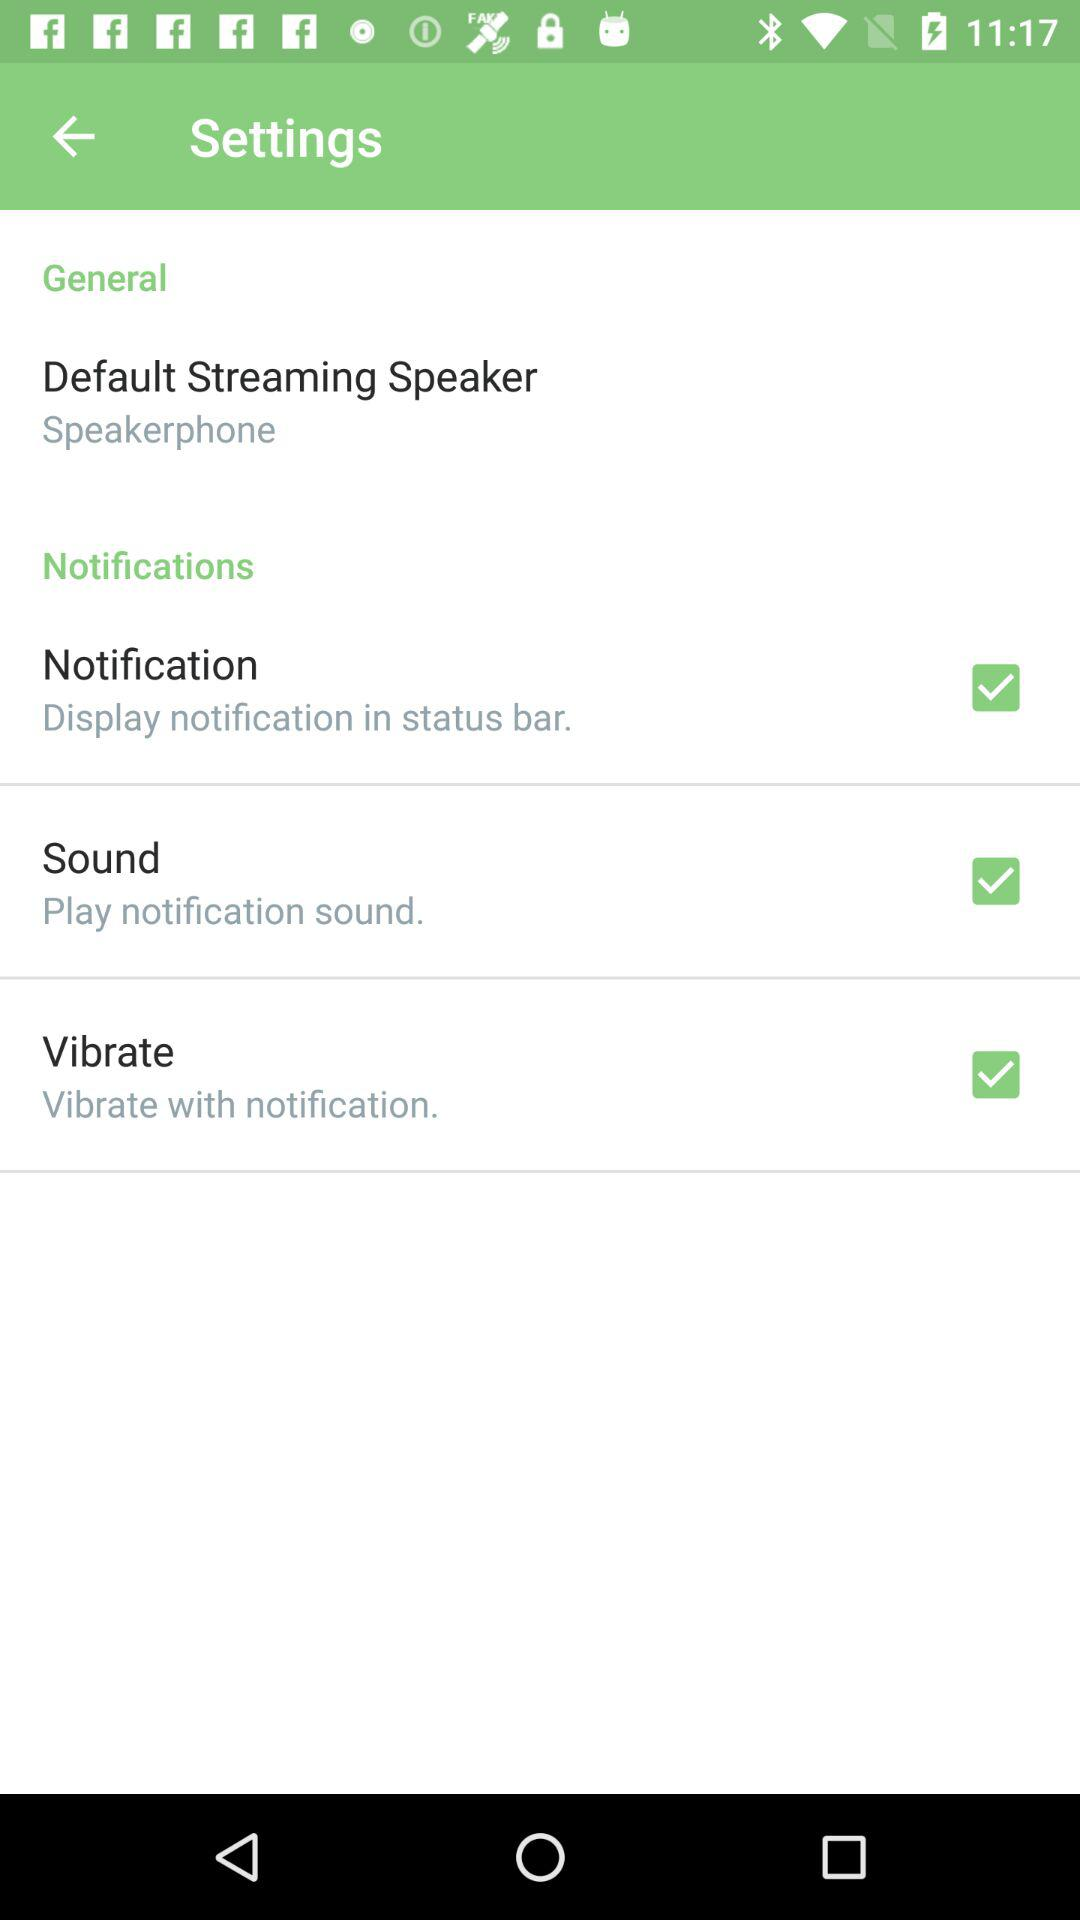Where the Notification display?
When the provided information is insufficient, respond with <no answer>. <no answer> 